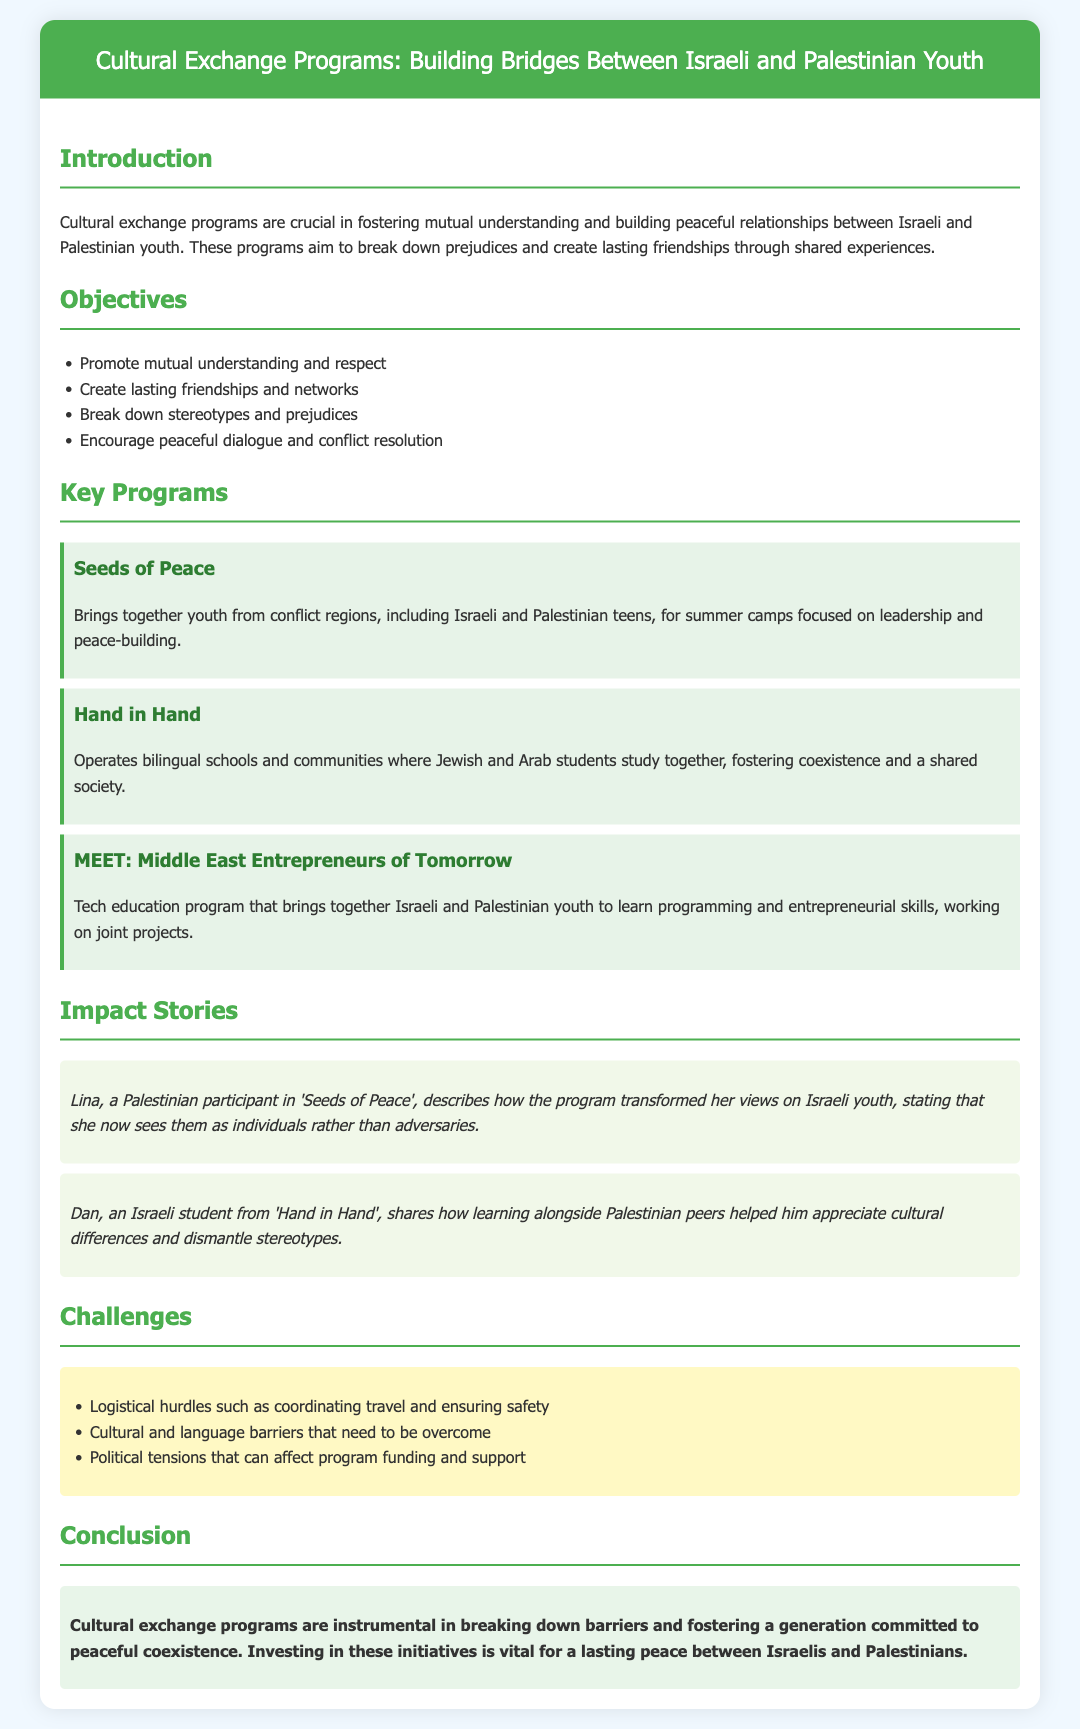What is the title of the presentation? The title of the presentation is stated at the top of the document, highlighting the main focus of the cultural exchange programs.
Answer: Cultural Exchange Programs: Building Bridges Between Israeli and Palestinian Youth What are the two main groups involved in the exchange programs? The document specifically mentions Israeli and Palestinian youth as the main participants in the cultural exchange programs.
Answer: Israeli and Palestinian youth What is one of the key objectives of these programs? The document lists objectives that aim to promote understanding and respect, among other goals.
Answer: Promote mutual understanding and respect Name a key program that focuses on peace-building. The document provides examples of specific programs that cater to youth from conflict regions, and one of them is explicitly related to peace-building.
Answer: Seeds of Peace Who described a transformative experience in 'Seeds of Peace'? The document includes personal stories from participants, and one participant is mentioned by name regarding her views on Israeli youth.
Answer: Lina What is a challenge faced by cultural exchange programs? Challenges are listed in the document, addressing various logistical and social issues.
Answer: Logistical hurdles In what type of education does MEET specialize? The document describes MEET in detail, highlighting its focus on a specific educational field relevant to technology.
Answer: Tech education What sentiment does the conclusion express regarding cultural exchange programs? The conclusion summarizes the importance of these cultural exchange programs in fostering peace for future generations.
Answer: Instrumental in breaking down barriers What is the impact of learning alongside peers according to Dan? Dan's story illustrates the effects of shared learning experiences in changing perceptions, particularly among youths.
Answer: Appreciate cultural differences 